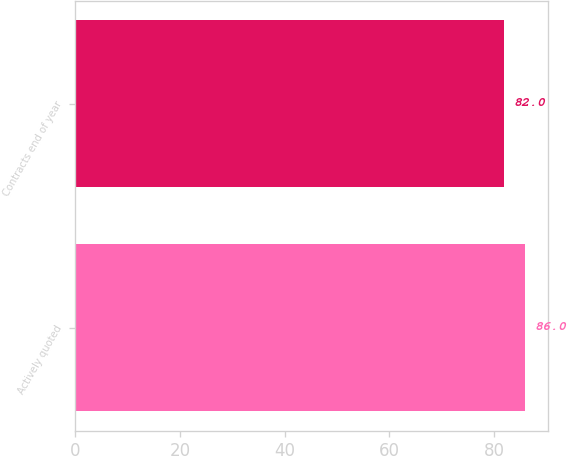Convert chart. <chart><loc_0><loc_0><loc_500><loc_500><bar_chart><fcel>Actively quoted<fcel>Contracts end of year<nl><fcel>86<fcel>82<nl></chart> 